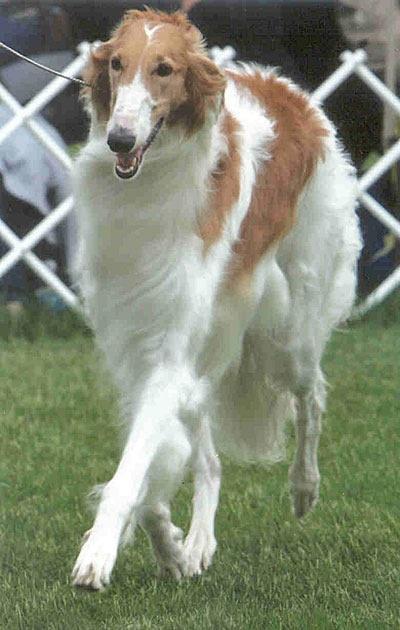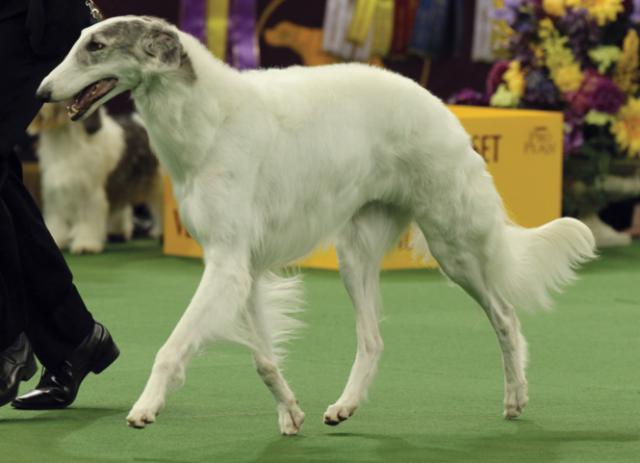The first image is the image on the left, the second image is the image on the right. Assess this claim about the two images: "One of the dogs is on artificial turf.". Correct or not? Answer yes or no. Yes. The first image is the image on the left, the second image is the image on the right. For the images shown, is this caption "All hounds shown are trotting on a green surface, and one of the dogs is trotting leftward alongside a person on green carpet." true? Answer yes or no. Yes. 